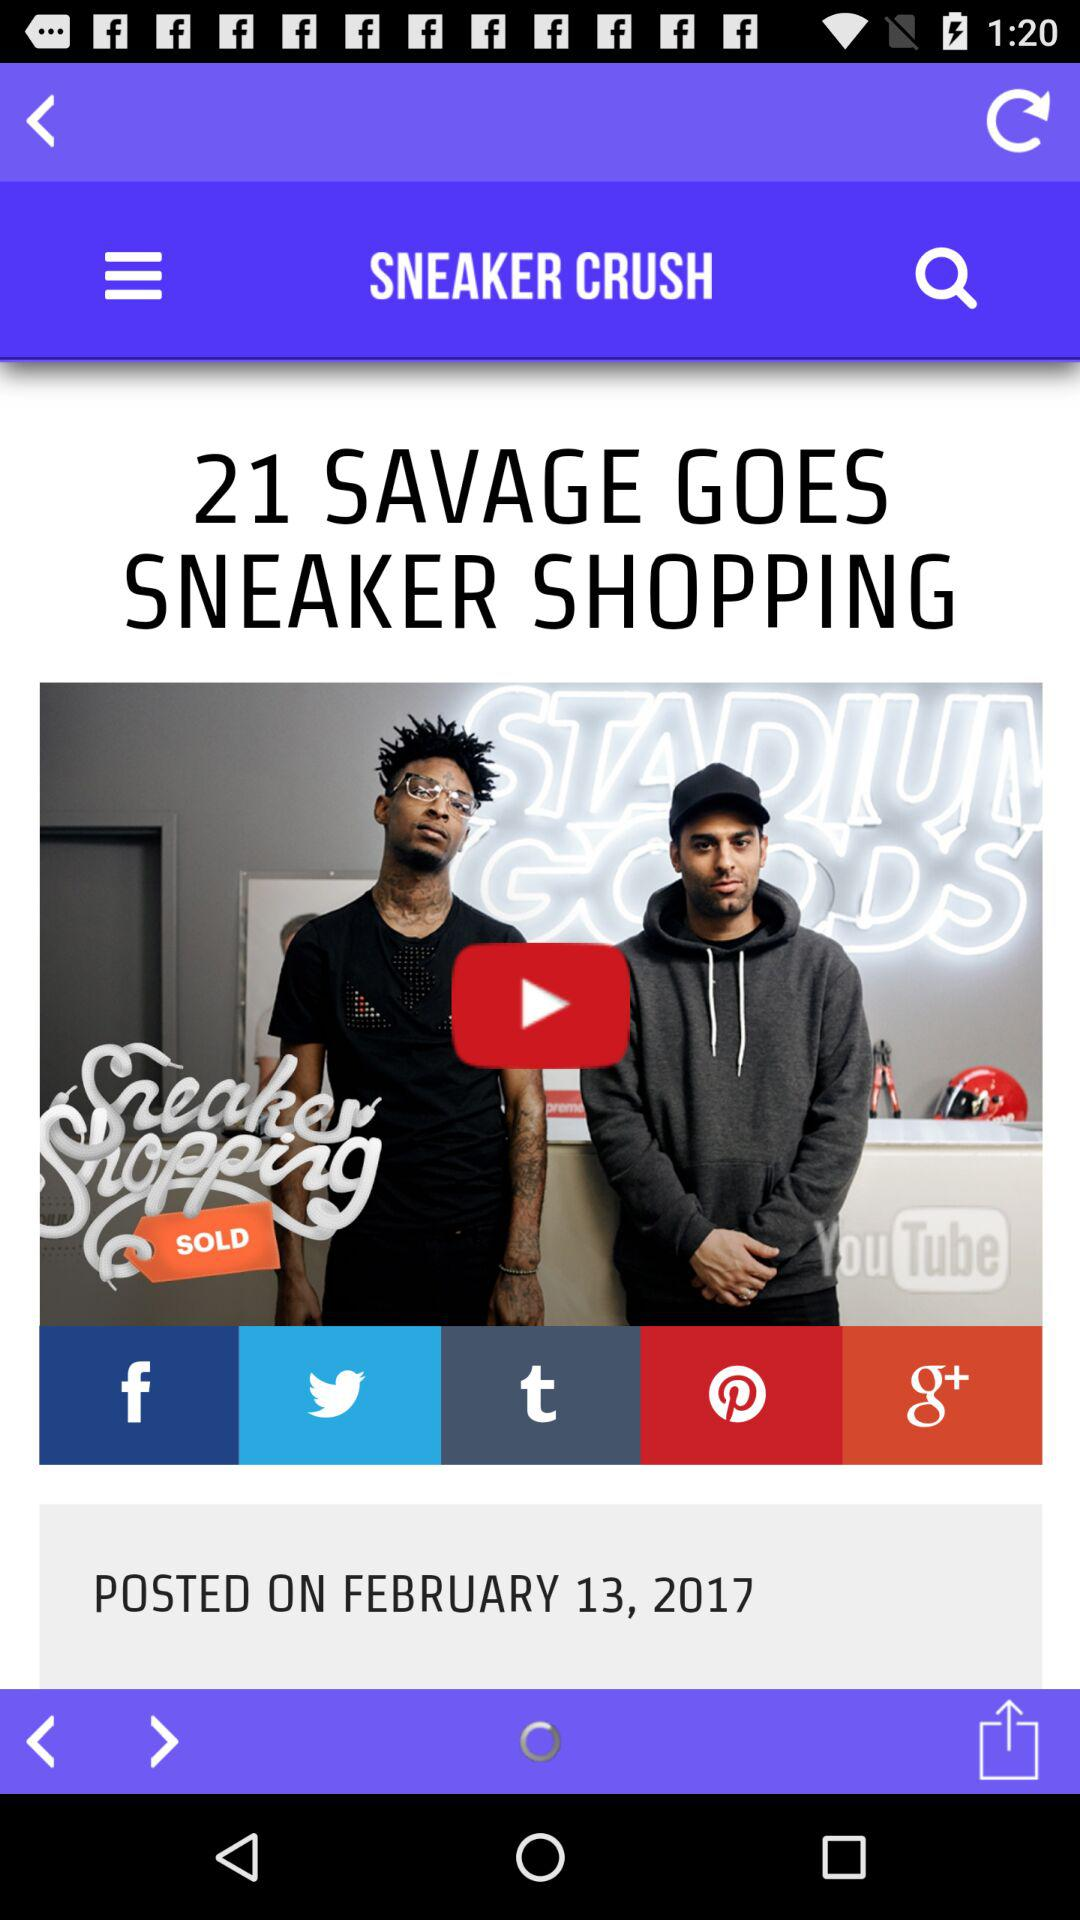What is the posted date? The posted date is February 13, 2017. 